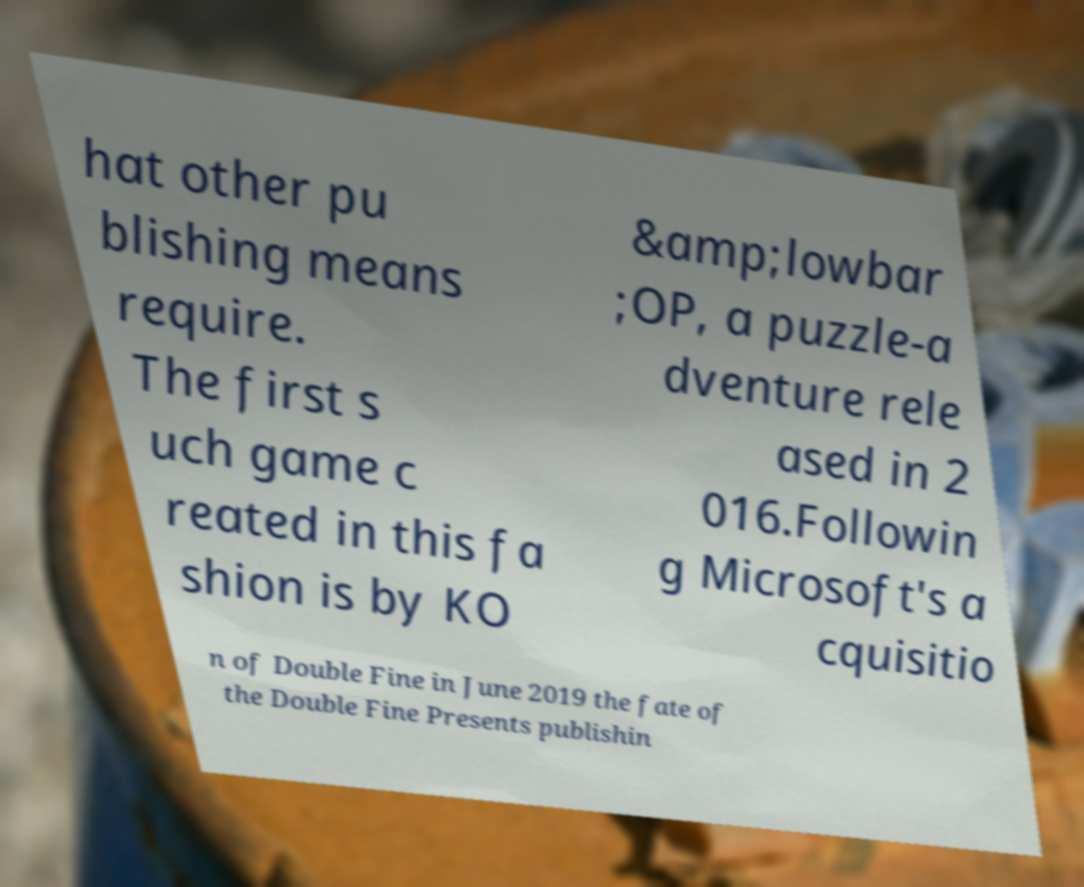What messages or text are displayed in this image? I need them in a readable, typed format. hat other pu blishing means require. The first s uch game c reated in this fa shion is by KO &amp;lowbar ;OP, a puzzle-a dventure rele ased in 2 016.Followin g Microsoft's a cquisitio n of Double Fine in June 2019 the fate of the Double Fine Presents publishin 